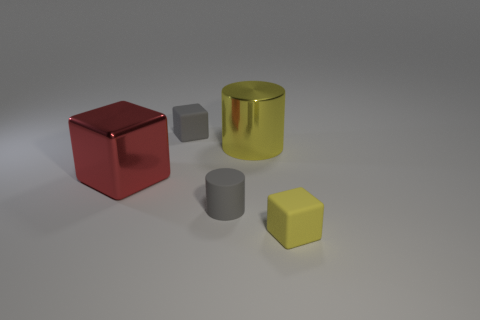Add 4 yellow shiny cylinders. How many objects exist? 9 Subtract all blocks. How many objects are left? 2 Add 3 gray objects. How many gray objects exist? 5 Subtract 0 green cylinders. How many objects are left? 5 Subtract all big green matte spheres. Subtract all tiny rubber cylinders. How many objects are left? 4 Add 1 gray rubber things. How many gray rubber things are left? 3 